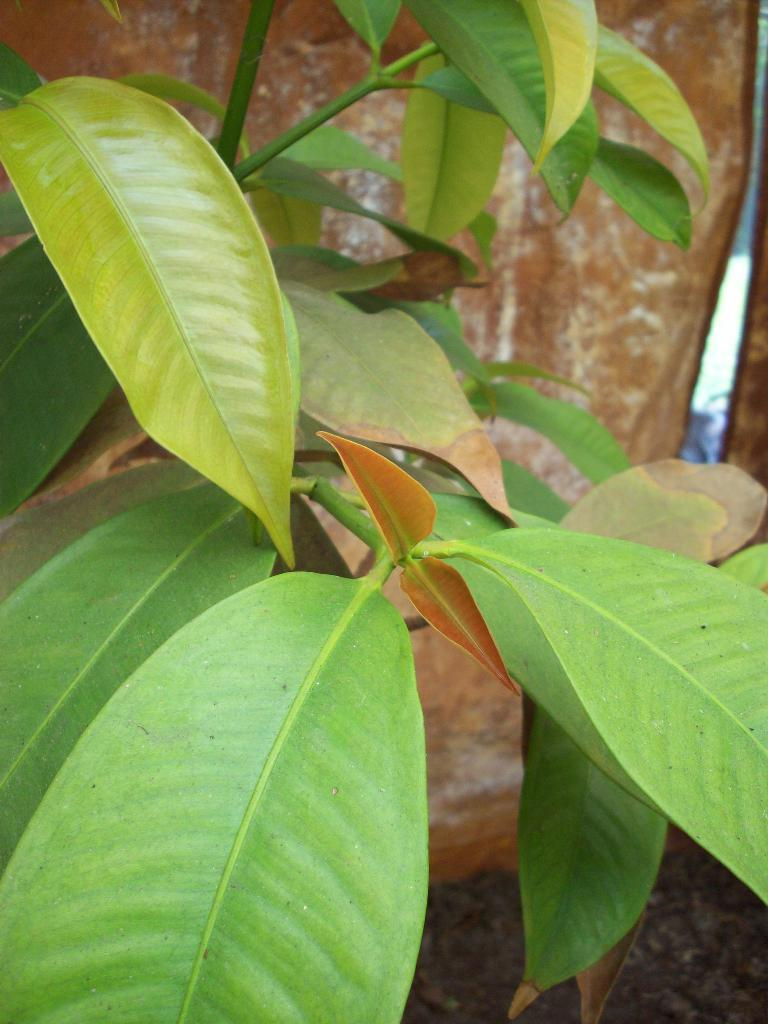What type of plant is visible in the image? There is a plant with leaves in the image. What is the plant placed in? There is a pot behind the plant. Where is the pot located? The pot is on the land. What type of bread is being served by the government in the image? There is no bread or government present in the image; it features a plant with leaves and a pot on the land. 